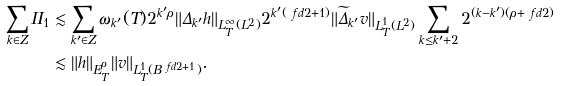<formula> <loc_0><loc_0><loc_500><loc_500>\sum _ { k \in Z } I I _ { 1 } & \lesssim \sum _ { k ^ { \prime } \in Z } \omega _ { k ^ { \prime } } ( T ) 2 ^ { k ^ { \prime } \rho } \| \Delta _ { k ^ { \prime } } h \| _ { L ^ { \infty } _ { T } ( L ^ { 2 } ) } 2 ^ { k ^ { \prime } ( \ f d 2 + 1 ) } \| \widetilde { \Delta } _ { k ^ { \prime } } v \| _ { L ^ { 1 } _ { T } ( L ^ { 2 } ) } \sum _ { k \leq k ^ { \prime } + 2 } 2 ^ { ( k - k ^ { \prime } ) ( \rho + \ f d 2 ) } \\ & \lesssim \| h \| _ { E ^ { \rho } _ { T } } \| v \| _ { L ^ { 1 } _ { T } ( B ^ { \ f d 2 + 1 } ) } .</formula> 